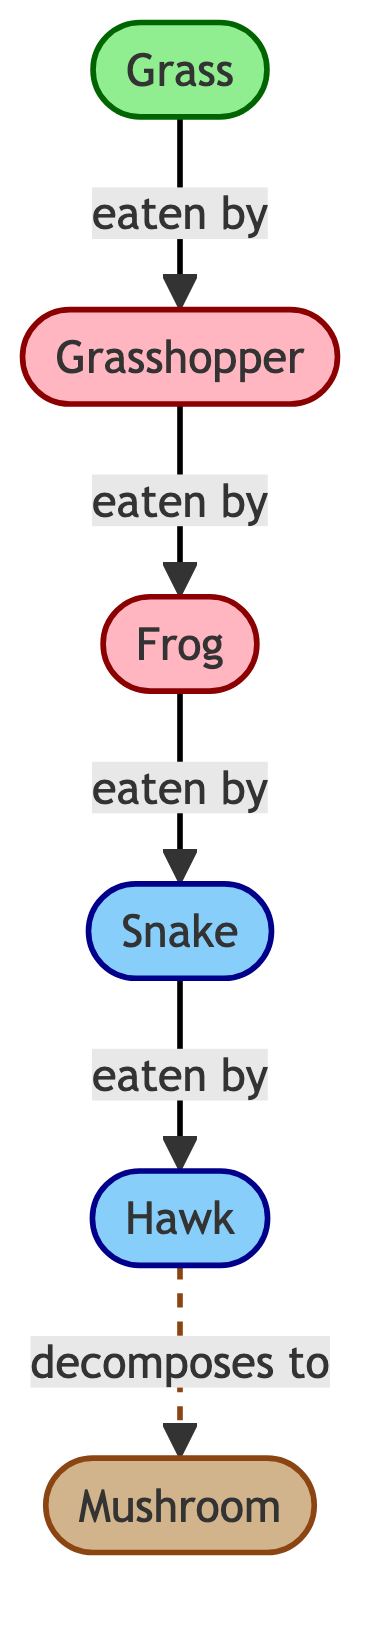What is the top predator in this food chain? The diagram shows the food chain with a clear flow from Grass to various consumers and predators. The top predator, which is at the apex of the food chain without any other organisms above it, is the Hawk.
Answer: Hawk How many consumers are present in the diagram? The diagram includes Grasshopper and Frog as consumers. There are two consumer nodes represented in the flow, so the total count is two.
Answer: 2 What does the Grasshopper eat? In the diagram, there is an arrow pointing from Grass to Grasshopper, indicating that Grasshopper eats Grass.
Answer: Grass Which organism is directly eaten by the Snake? The flow from Frog to Snake indicates that the Snake eats the Frog directly. This relationship can be identified by following the arrows in the diagram.
Answer: Frog What role does the Mushroom play in the ecosystem? The diagram shows that Mushroom is a decomposer, as indicated by its classification and the dashed arrow pointing from Hawk to Mushroom, which suggests it breaks down organic matter after the Hawk.
Answer: Decomposer How many total arrows (edges) are present in the diagram? By examining the diagram, the arrows connecting the nodes illustrate the eating relationships and the decomposition pathway. There are five solid arrows and one dashed arrow, giving a total of six arrows.
Answer: 6 Which organism is at the base of the food chain? The diagram starts with Grass as the primary producer and base organism, indicated by its position at the beginning of the flow.
Answer: Grass What happens to the Hawk after it dies, according to the diagram? The dashed arrow that connects Hawk to Mushroom indicates that after the Hawk dies, it decomposes into the Mushroom. This illustrates a natural process in ecosystem cycling.
Answer: Decomposes to Mushroom What eats the Grasshopper? The flow shows that the Frog eats the Grasshopper, as indicated by the arrow pointing from Grasshopper to Frog. This relationship can be traced directly through the diagram.
Answer: Frog 